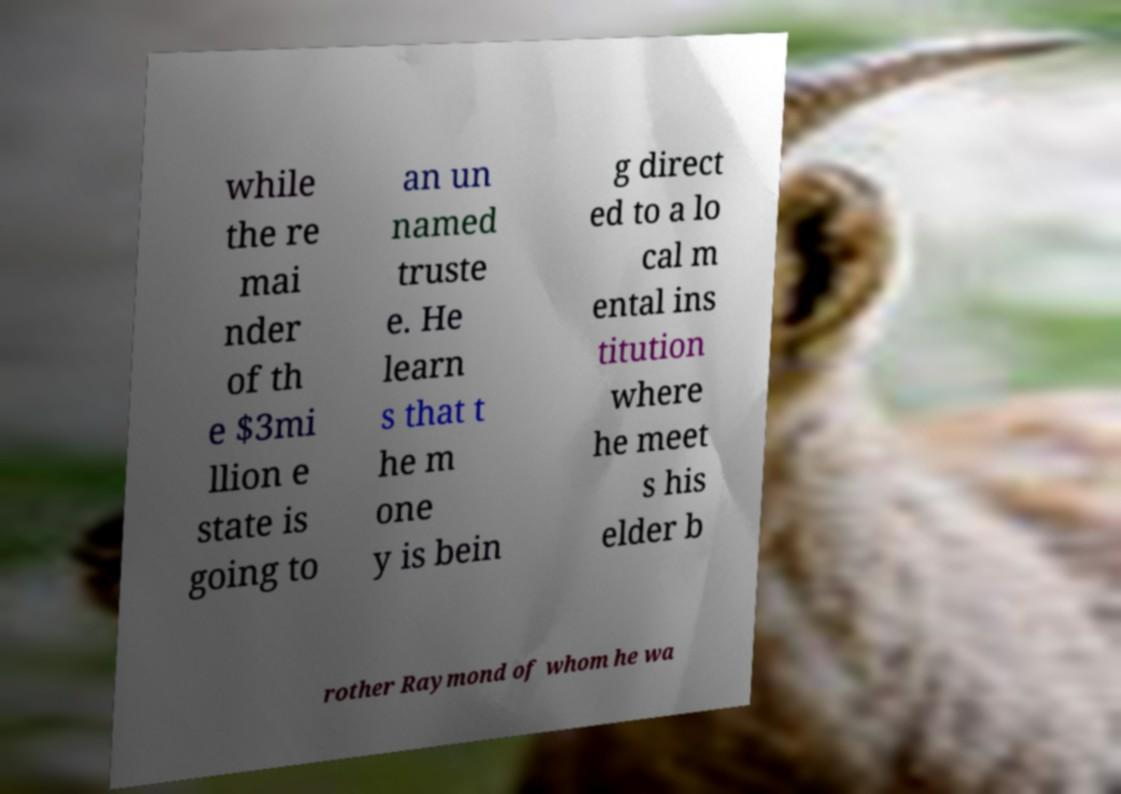Please read and relay the text visible in this image. What does it say? while the re mai nder of th e $3mi llion e state is going to an un named truste e. He learn s that t he m one y is bein g direct ed to a lo cal m ental ins titution where he meet s his elder b rother Raymond of whom he wa 